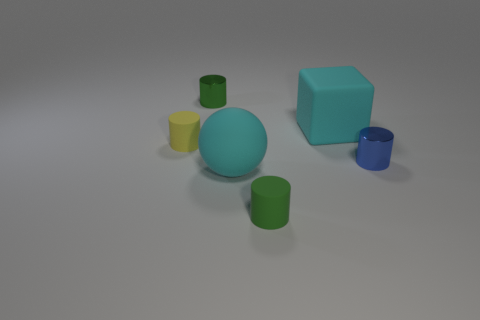There is a block that is the same size as the cyan matte sphere; what is its material?
Provide a short and direct response. Rubber. What number of objects are big cyan matte things that are to the right of the cyan rubber ball or small metallic objects left of the big cyan matte sphere?
Give a very brief answer. 2. Are there any tiny blue rubber things that have the same shape as the tiny yellow matte thing?
Your answer should be very brief. No. What material is the ball that is the same color as the cube?
Keep it short and to the point. Rubber. How many rubber objects are tiny cylinders or big cyan cubes?
Make the answer very short. 3. How many big cubes are made of the same material as the yellow thing?
Your answer should be compact. 1. What is the color of the block that is the same material as the tiny yellow cylinder?
Ensure brevity in your answer.  Cyan. There is a shiny thing right of the green rubber cylinder; does it have the same size as the rubber sphere?
Offer a very short reply. No. The other metallic object that is the same shape as the green shiny thing is what color?
Your answer should be very brief. Blue. What is the shape of the metallic object right of the big cyan rubber ball in front of the small green object that is behind the small yellow matte object?
Provide a succinct answer. Cylinder. 